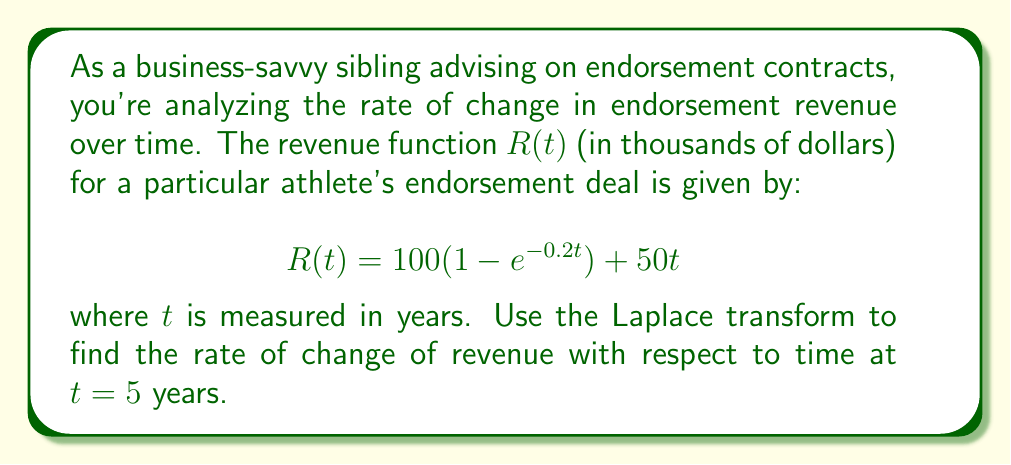Teach me how to tackle this problem. To solve this problem, we'll follow these steps:

1) First, we need to find the derivative of $R(t)$ with respect to $t$. This represents the rate of change of revenue over time.

   $$\frac{dR}{dt} = 100(0.2e^{-0.2t}) + 50$$

2) Now, we need to find the Laplace transform of this derivative. Let's call the Laplace transform of $\frac{dR}{dt}$ as $F(s)$.

   $$F(s) = \mathcal{L}\left\{\frac{dR}{dt}\right\} = \mathcal{L}\{100(0.2e^{-0.2t}) + 50\}$$

3) Using linearity property of Laplace transform:

   $$F(s) = 100(0.2)\mathcal{L}\{e^{-0.2t}\} + 50\mathcal{L}\{1\}$$

4) We know that $\mathcal{L}\{e^{-at}\} = \frac{1}{s+a}$ and $\mathcal{L}\{1\} = \frac{1}{s}$. Applying these:

   $$F(s) = \frac{20}{s+0.2} + \frac{50}{s}$$

5) To find the rate of change at $t=5$, we need to use the inverse Laplace transform and then evaluate at $t=5$. However, we can use the Final Value Theorem, which states that for a function $f(t)$ with Laplace transform $F(s)$:

   $$\lim_{t \to \infty} f(t) = \lim_{s \to 0} sF(s)$$

6) In our case, we're interested in $f(5)$, not the limit as $t$ approaches infinity. But we can modify the theorem:

   $$f(5) = \lim_{s \to 0} sF(s)e^{5s}$$

7) Applying this to our $F(s)$:

   $$\frac{dR}{dt}(5) = \lim_{s \to 0} s\left(\frac{20}{s+0.2} + \frac{50}{s}\right)e^{5s}$$

8) Simplifying:

   $$\frac{dR}{dt}(5) = \lim_{s \to 0} \left(\frac{20s}{s+0.2} + 50\right)e^{5s}$$

9) As $s$ approaches 0, $\frac{20s}{s+0.2}$ approaches 0, and $e^{5s}$ approaches 1. Therefore:

   $$\frac{dR}{dt}(5) = 50$$

Thus, the rate of change of revenue with respect to time at $t = 5$ years is 50 thousand dollars per year.
Answer: $50$ thousand dollars per year 